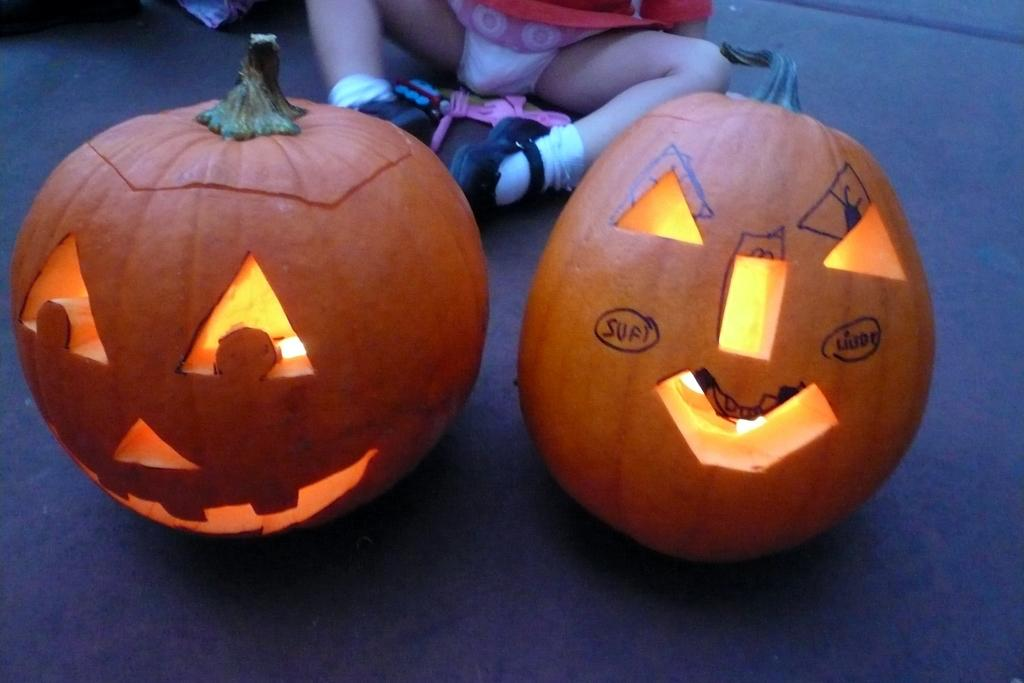What objects are present in the image that are related to Halloween? There are two carved pumpkins in the image. Where are the pumpkins placed? The pumpkins are kept on a surface. Can you describe anything about the person in the background? The person's leg is visible in the background, and they are wearing shoes and socks. What invention can be seen in the image that revolutionized the way people sleep? There is no invention related to sleep in the image; it features two carved pumpkins and a person's leg with shoes and socks. How many beds are visible in the image? There are no beds present in the image. 